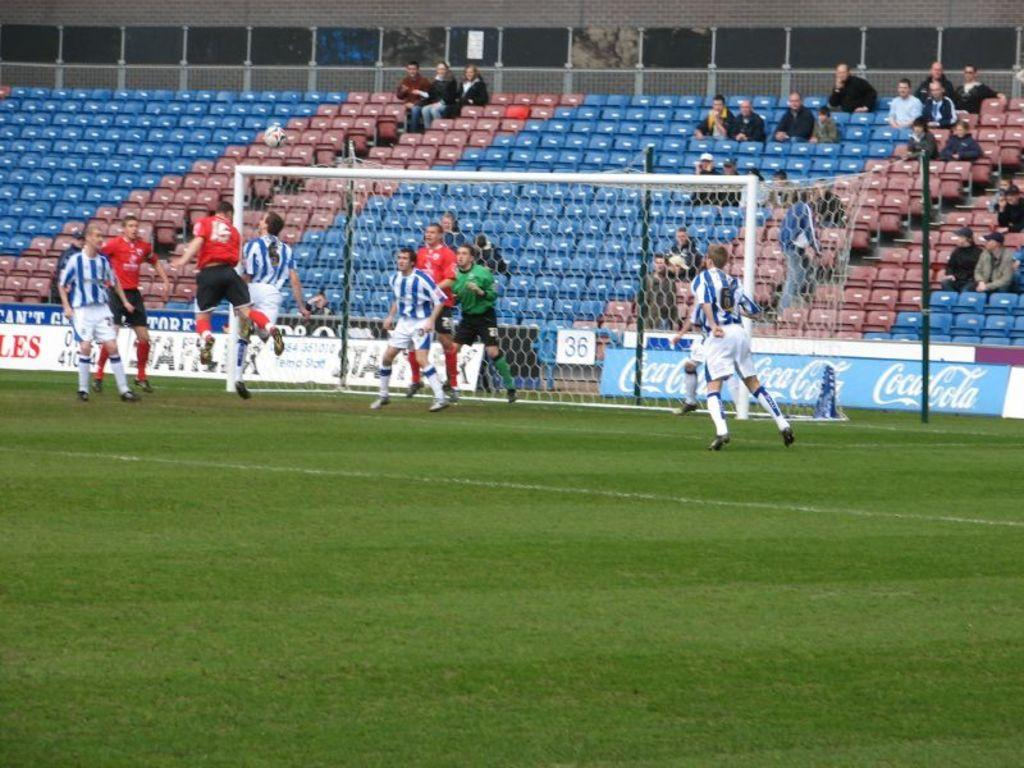<image>
Write a terse but informative summary of the picture. a soccer field with a sign on the fence that says 36 